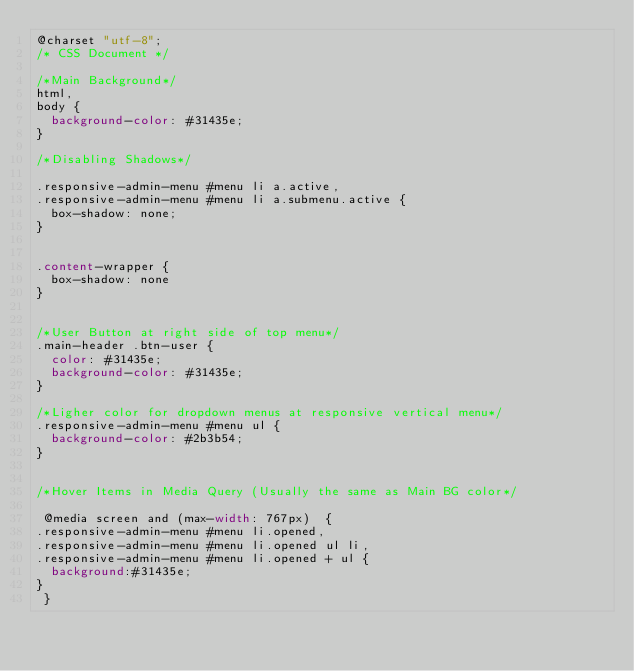Convert code to text. <code><loc_0><loc_0><loc_500><loc_500><_CSS_>@charset "utf-8";
/* CSS Document */

/*Main Background*/
html,
body {
	background-color: #31435e;
}

/*Disabling Shadows*/

.responsive-admin-menu #menu li a.active,
.responsive-admin-menu #menu li a.submenu.active {
	box-shadow: none;
}


.content-wrapper {
	box-shadow: none
}


/*User Button at right side of top menu*/
.main-header .btn-user {
	color: #31435e;
	background-color: #31435e;
}

/*Ligher color for dropdown menus at responsive vertical menu*/
.responsive-admin-menu #menu ul {
	background-color: #2b3b54;
}


/*Hover Items in Media Query (Usually the same as Main BG color*/

 @media screen and (max-width: 767px)  {
.responsive-admin-menu #menu li.opened,
.responsive-admin-menu #menu li.opened ul li,
.responsive-admin-menu #menu li.opened + ul {
	background:#31435e;
}
 }</code> 